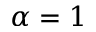<formula> <loc_0><loc_0><loc_500><loc_500>\alpha = 1</formula> 